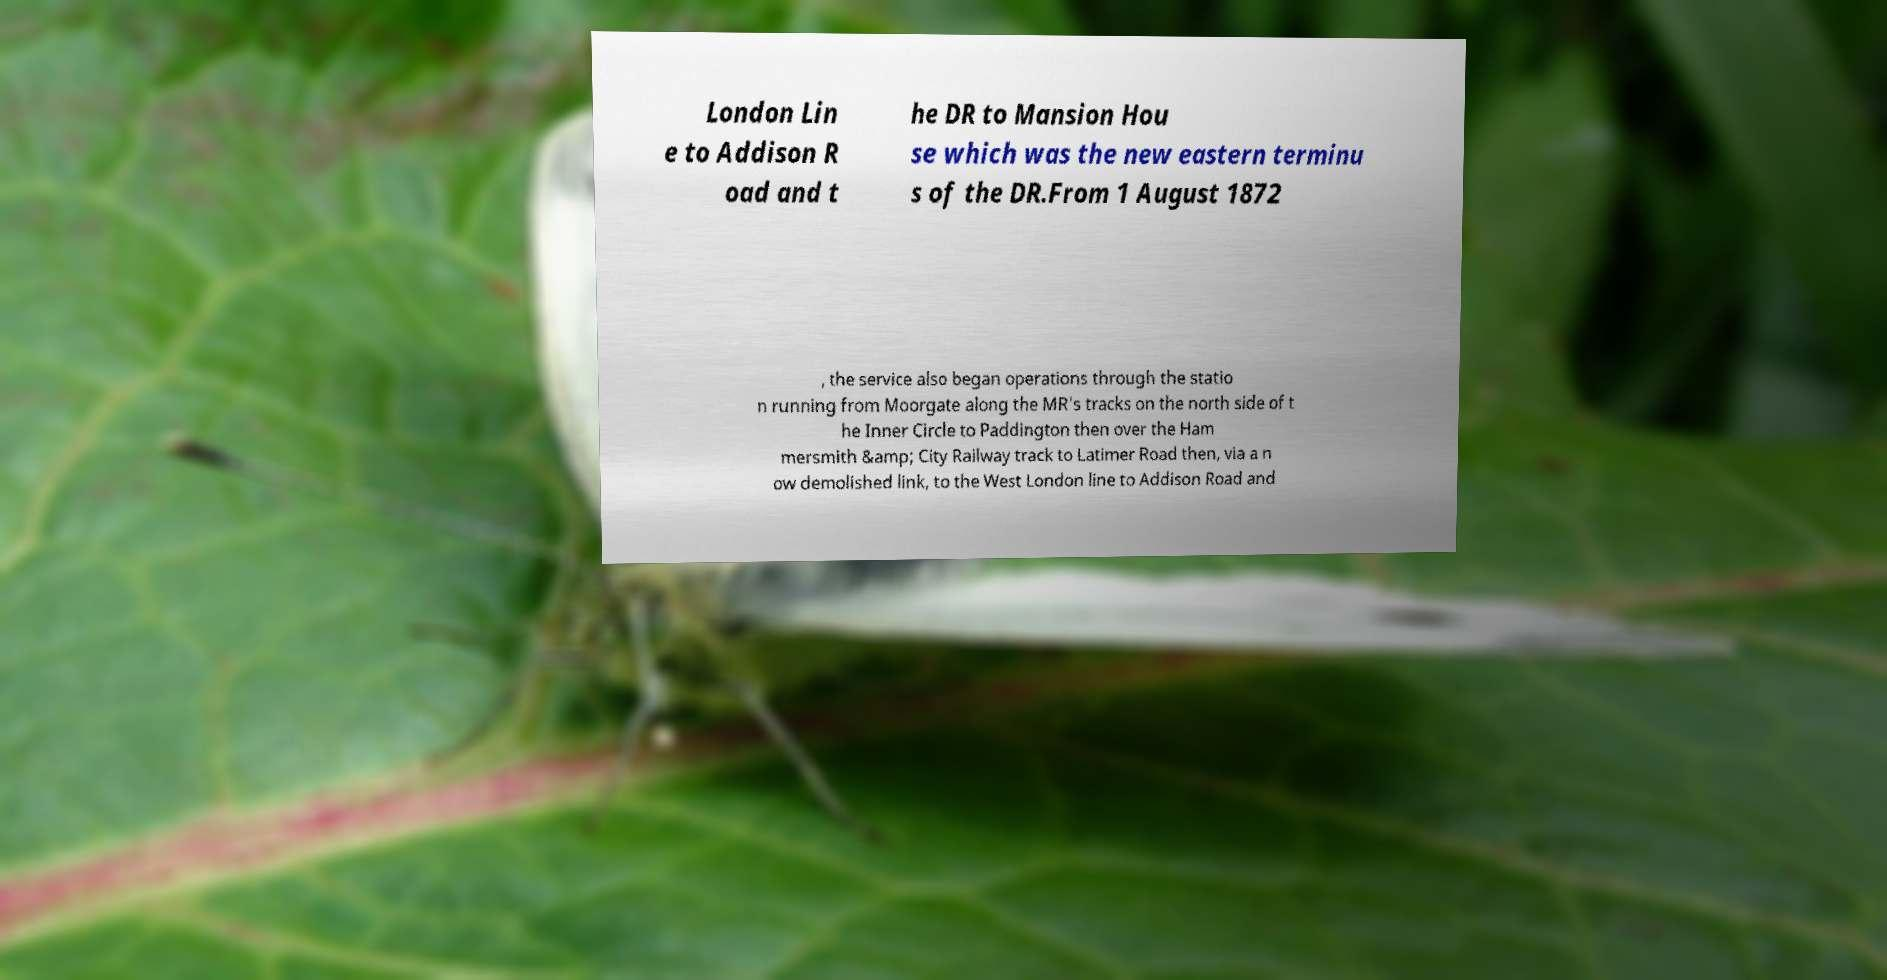I need the written content from this picture converted into text. Can you do that? London Lin e to Addison R oad and t he DR to Mansion Hou se which was the new eastern terminu s of the DR.From 1 August 1872 , the service also began operations through the statio n running from Moorgate along the MR's tracks on the north side of t he Inner Circle to Paddington then over the Ham mersmith &amp; City Railway track to Latimer Road then, via a n ow demolished link, to the West London line to Addison Road and 